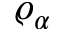Convert formula to latex. <formula><loc_0><loc_0><loc_500><loc_500>\varrho _ { \alpha }</formula> 